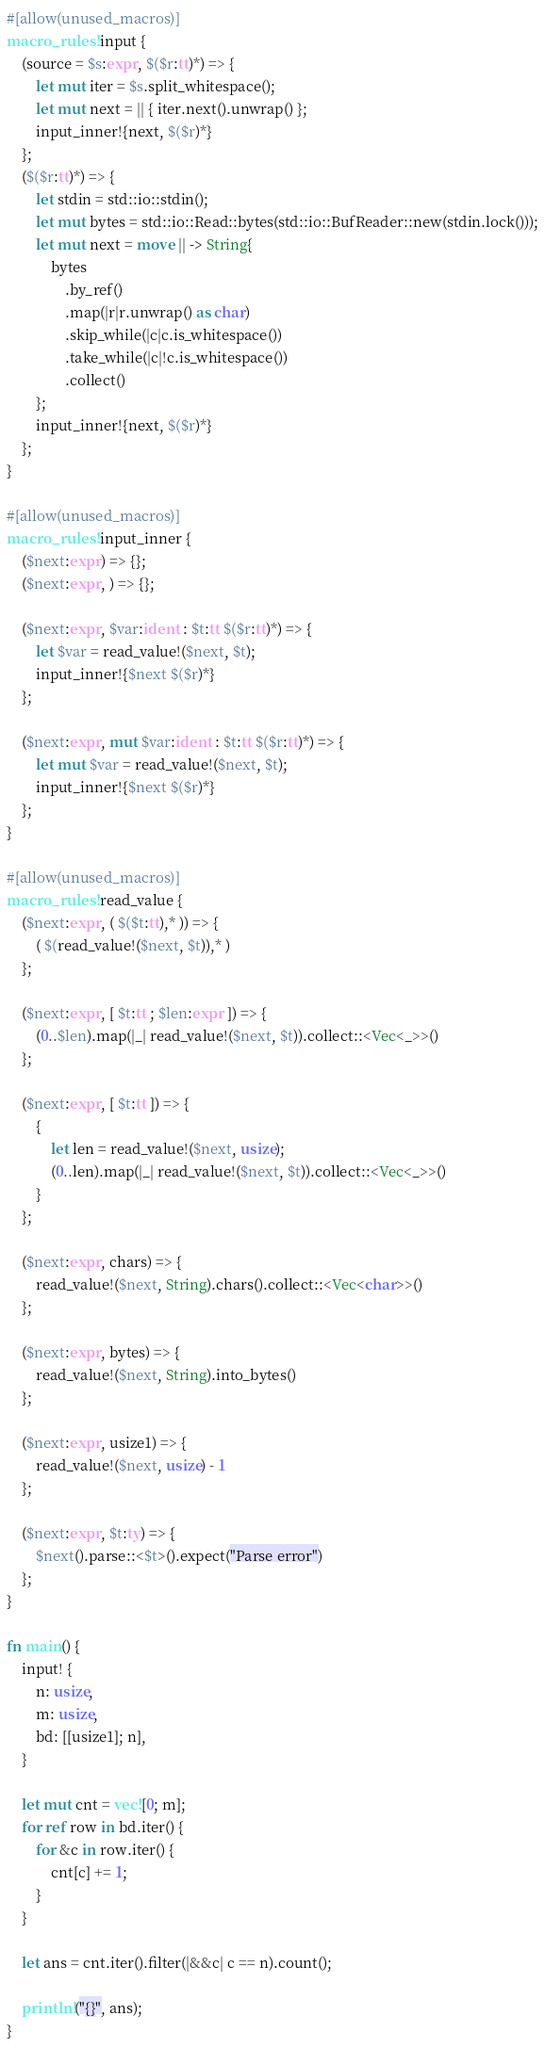Convert code to text. <code><loc_0><loc_0><loc_500><loc_500><_Rust_>#[allow(unused_macros)]
macro_rules! input {
    (source = $s:expr, $($r:tt)*) => {
        let mut iter = $s.split_whitespace();
        let mut next = || { iter.next().unwrap() };
        input_inner!{next, $($r)*}
    };
    ($($r:tt)*) => {
        let stdin = std::io::stdin();
        let mut bytes = std::io::Read::bytes(std::io::BufReader::new(stdin.lock()));
        let mut next = move || -> String{
            bytes
                .by_ref()
                .map(|r|r.unwrap() as char)
                .skip_while(|c|c.is_whitespace())
                .take_while(|c|!c.is_whitespace())
                .collect()
        };
        input_inner!{next, $($r)*}
    };
}

#[allow(unused_macros)]
macro_rules! input_inner {
    ($next:expr) => {};
    ($next:expr, ) => {};

    ($next:expr, $var:ident : $t:tt $($r:tt)*) => {
        let $var = read_value!($next, $t);
        input_inner!{$next $($r)*}
    };

    ($next:expr, mut $var:ident : $t:tt $($r:tt)*) => {
        let mut $var = read_value!($next, $t);
        input_inner!{$next $($r)*}
    };
}

#[allow(unused_macros)]
macro_rules! read_value {
    ($next:expr, ( $($t:tt),* )) => {
        ( $(read_value!($next, $t)),* )
    };

    ($next:expr, [ $t:tt ; $len:expr ]) => {
        (0..$len).map(|_| read_value!($next, $t)).collect::<Vec<_>>()
    };

    ($next:expr, [ $t:tt ]) => {
        {
            let len = read_value!($next, usize);
            (0..len).map(|_| read_value!($next, $t)).collect::<Vec<_>>()
        }
    };

    ($next:expr, chars) => {
        read_value!($next, String).chars().collect::<Vec<char>>()
    };

    ($next:expr, bytes) => {
        read_value!($next, String).into_bytes()
    };

    ($next:expr, usize1) => {
        read_value!($next, usize) - 1
    };

    ($next:expr, $t:ty) => {
        $next().parse::<$t>().expect("Parse error")
    };
}

fn main() {
    input! {
        n: usize,
        m: usize,
        bd: [[usize1]; n],
    }

    let mut cnt = vec![0; m];
    for ref row in bd.iter() {
        for &c in row.iter() {
            cnt[c] += 1;
        }
    }

    let ans = cnt.iter().filter(|&&c| c == n).count();

    println!("{}", ans);
}
</code> 